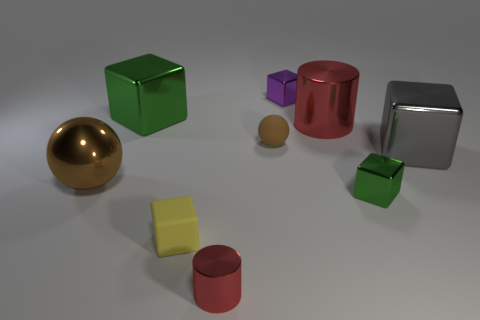Subtract all yellow blocks. How many blocks are left? 4 Subtract all small yellow cubes. How many cubes are left? 4 Subtract all cyan blocks. Subtract all cyan cylinders. How many blocks are left? 5 Add 1 brown things. How many objects exist? 10 Subtract all spheres. How many objects are left? 7 Add 6 big brown metallic things. How many big brown metallic things are left? 7 Add 3 cyan blocks. How many cyan blocks exist? 3 Subtract 0 cyan cylinders. How many objects are left? 9 Subtract all tiny gray matte blocks. Subtract all big gray objects. How many objects are left? 8 